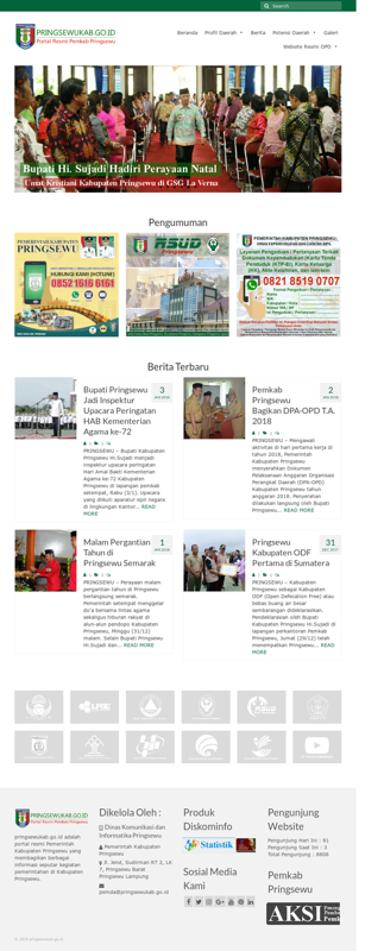What is the contact number provided on the website? For inquiries or further information, the website lists two contact numbers: 0852 1616 6161 and 0821 3519 0707, allowing visitors to reach out via these Indonesian phone numbers. 